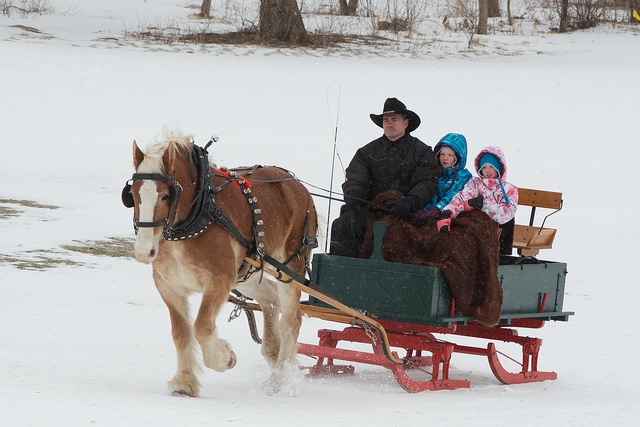Describe the objects in this image and their specific colors. I can see horse in lightgray, brown, tan, maroon, and black tones, people in lightgray, black, brown, gray, and maroon tones, people in lightgray, black, darkgray, lavender, and brown tones, and people in lightgray, black, teal, blue, and darkblue tones in this image. 